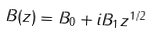Convert formula to latex. <formula><loc_0><loc_0><loc_500><loc_500>B ( z ) = B _ { 0 } + i B _ { 1 } z ^ { 1 / 2 }</formula> 